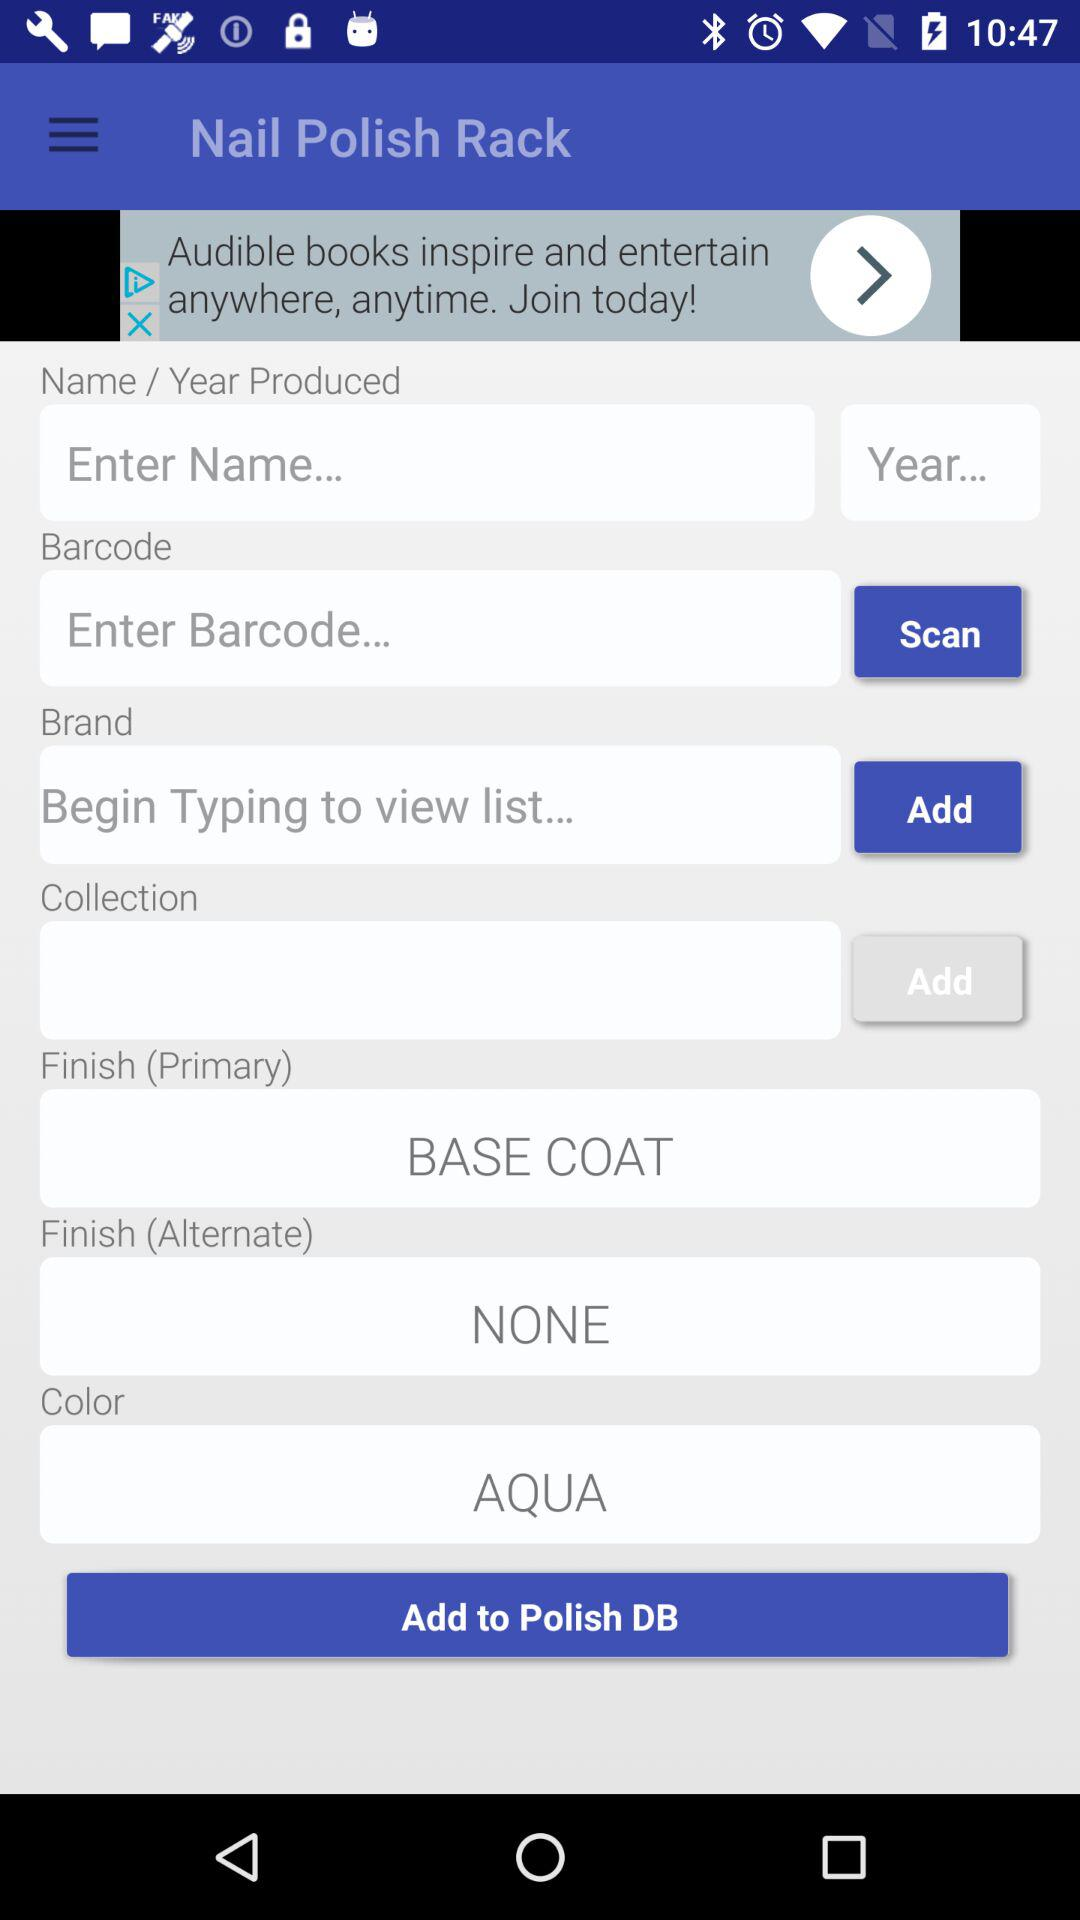What is the "Finish (Primary)"? The "Finish (Primary)" is "BASE COAT". 